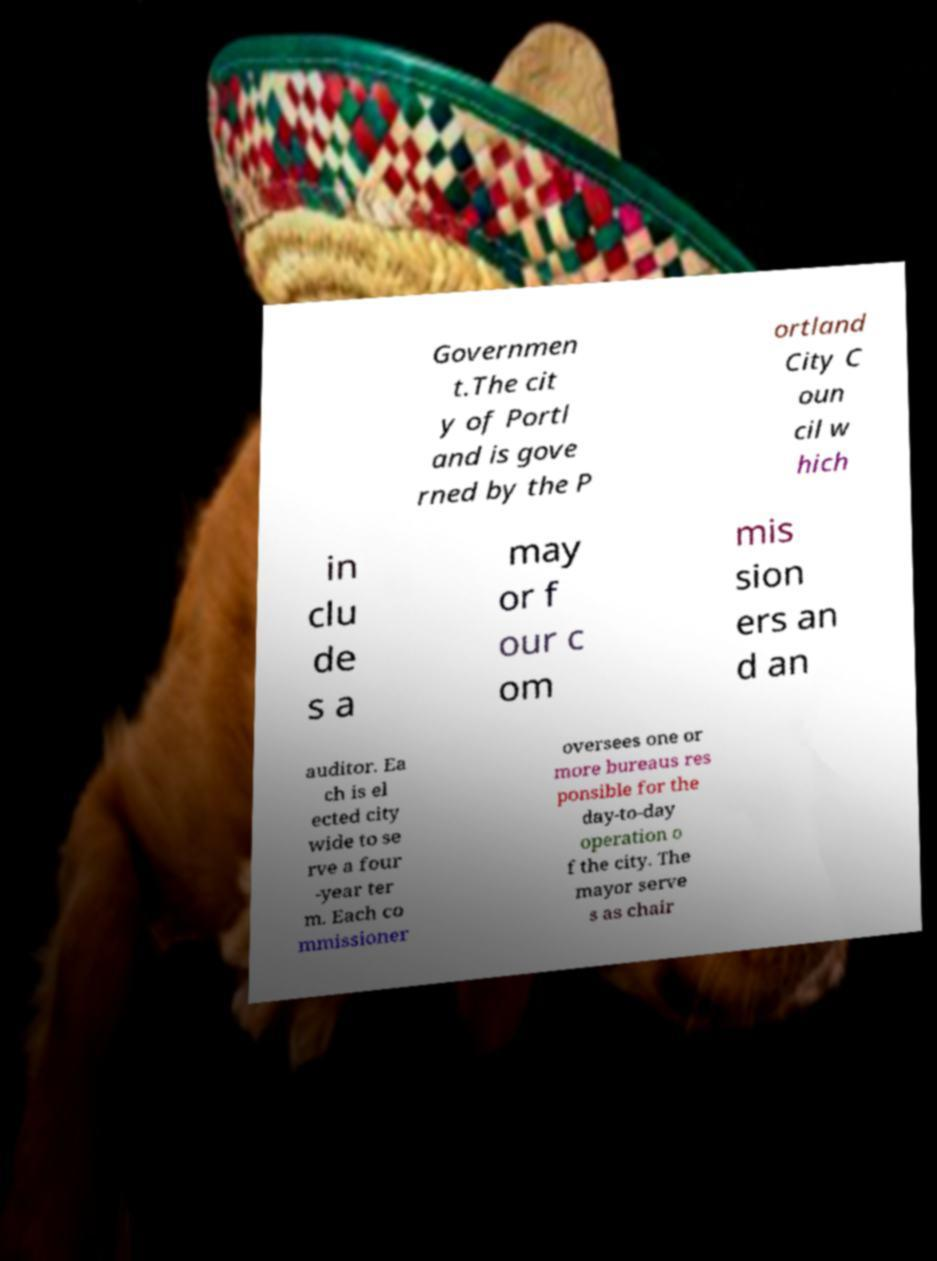Can you read and provide the text displayed in the image?This photo seems to have some interesting text. Can you extract and type it out for me? Governmen t.The cit y of Portl and is gove rned by the P ortland City C oun cil w hich in clu de s a may or f our c om mis sion ers an d an auditor. Ea ch is el ected city wide to se rve a four -year ter m. Each co mmissioner oversees one or more bureaus res ponsible for the day-to-day operation o f the city. The mayor serve s as chair 